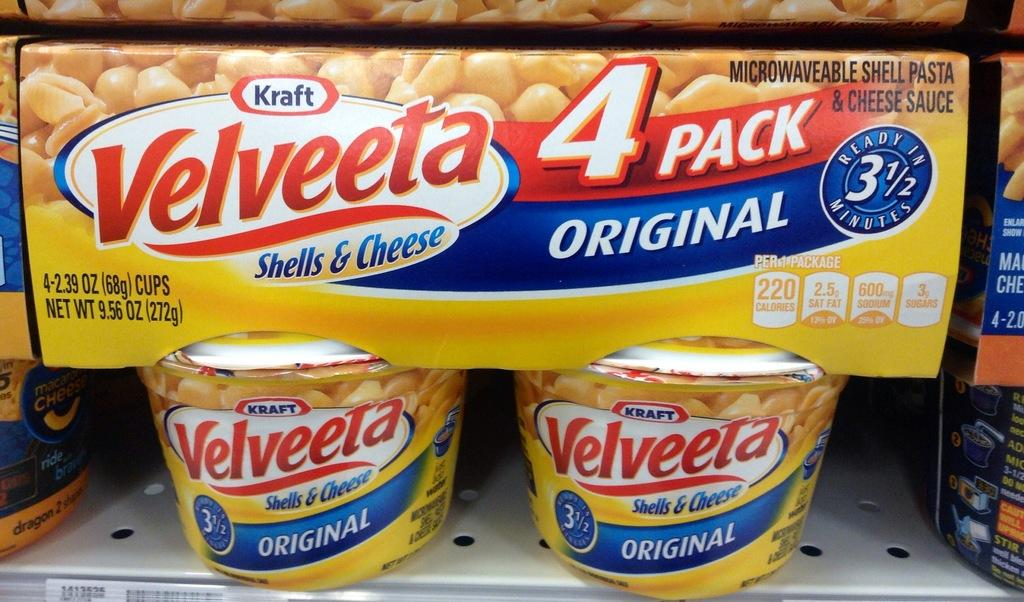What type of objects can be seen in the image? There are cups and boxes in the image. What else can be observed in the image? There is text visible in the image. What type of comfort can be seen in the image? There is no reference to comfort in the image, as it features cups, boxes, and text. What type of leaf is visible in the image? There is no leaf present in the image. 